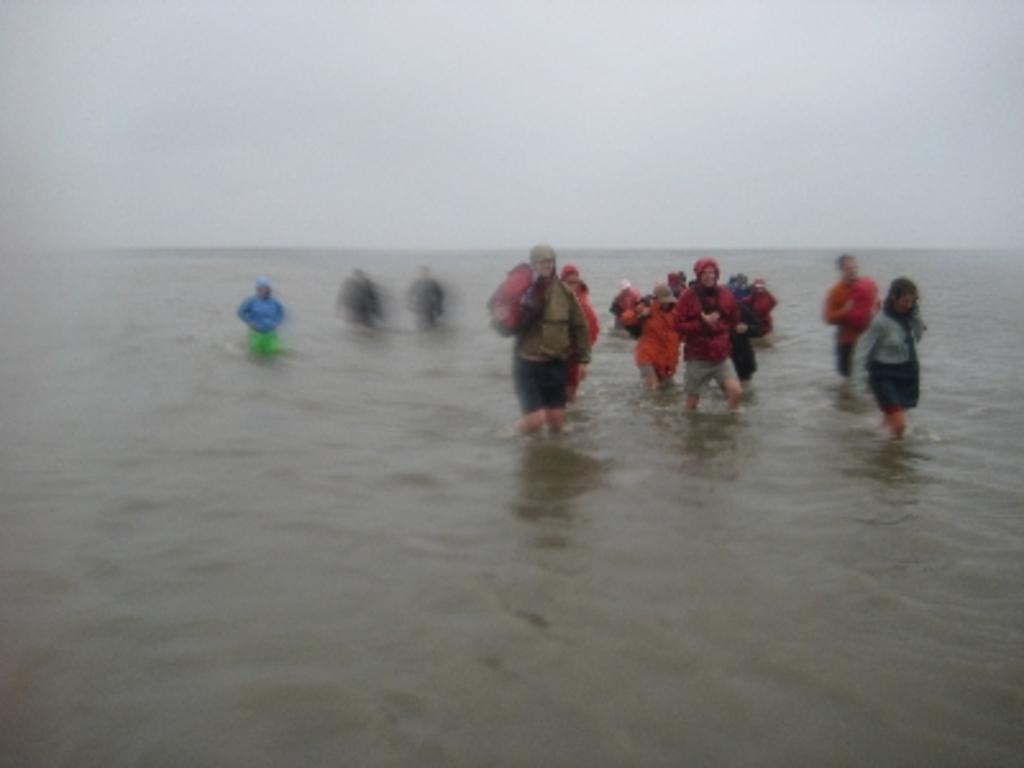What is at the bottom of the image? There is water at the bottom of the image. What is visible at the top of the image? The sky is visible at the top of the image. What are the people in the image doing? There are people walking in the water. What is the level of shame felt by the people walking in the water? There is no indication of shame or any emotions in the image, as it only shows people walking in the water. 